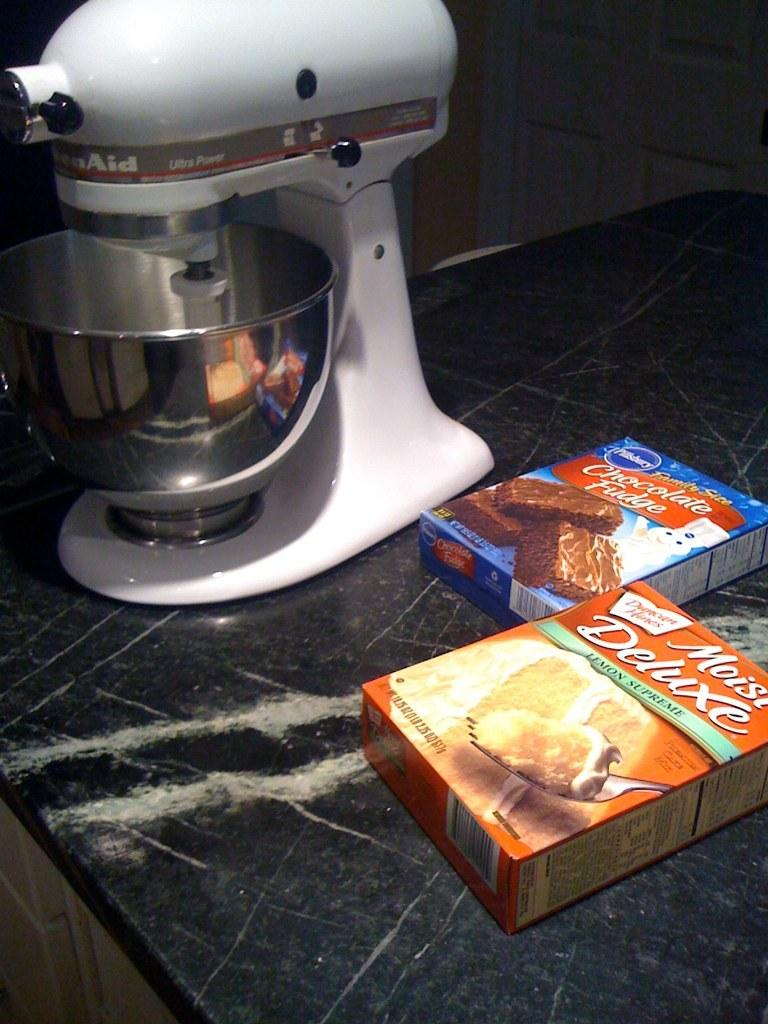What type of objects can be seen in the image? There are boxes in the image. Can you describe the machine in the image? There is a white color machine in the image. What is the surface made of where the objects are placed? The objects are on a stone surface. What information is provided on the boxes? The boxes have labels with photos of food items. Can you see any turkeys or crows near the seashore in the image? There is no seashore, turkey, or crow present in the image. 